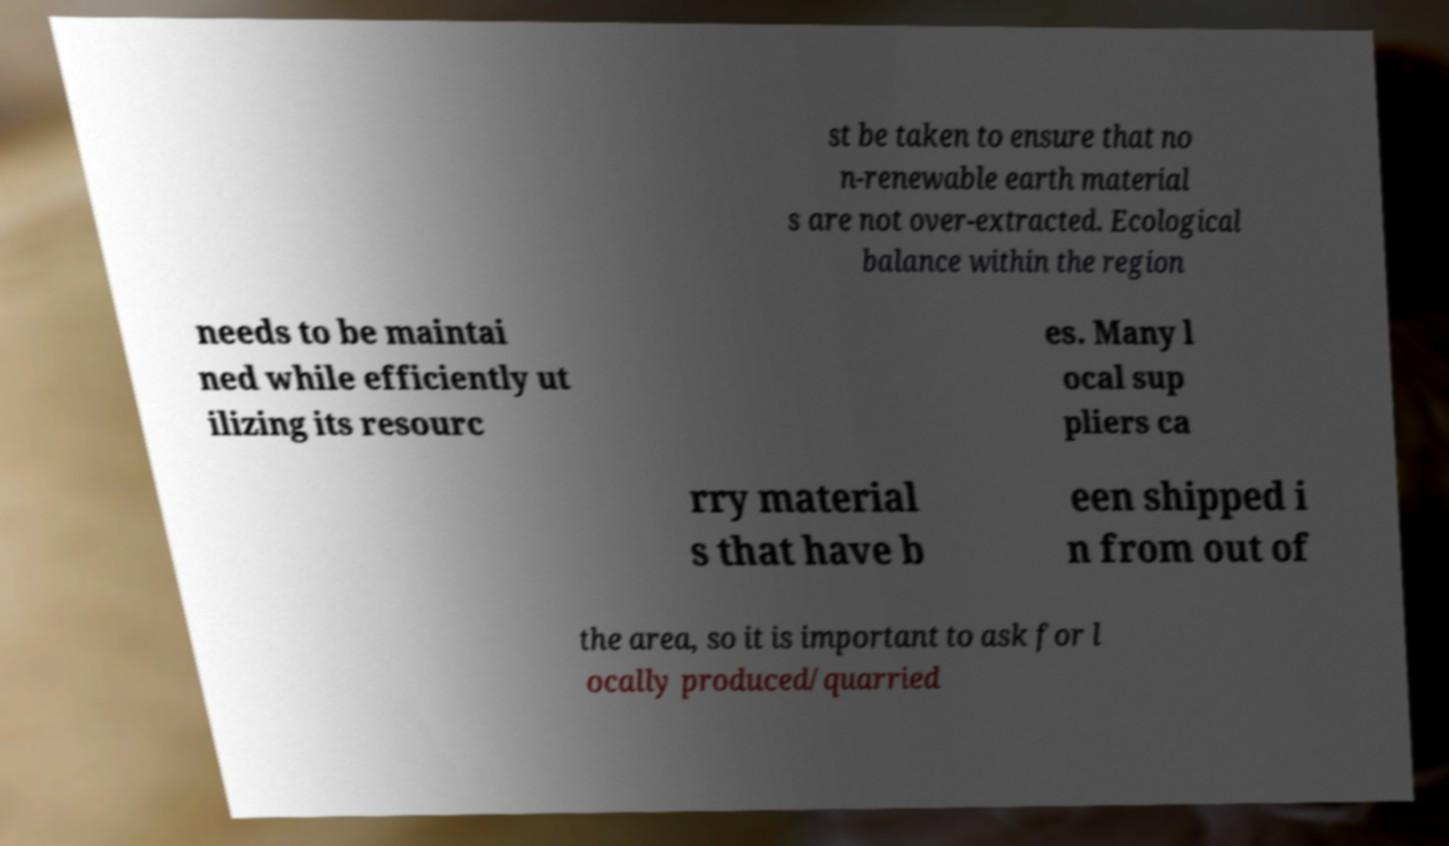Can you read and provide the text displayed in the image?This photo seems to have some interesting text. Can you extract and type it out for me? st be taken to ensure that no n-renewable earth material s are not over-extracted. Ecological balance within the region needs to be maintai ned while efficiently ut ilizing its resourc es. Many l ocal sup pliers ca rry material s that have b een shipped i n from out of the area, so it is important to ask for l ocally produced/quarried 